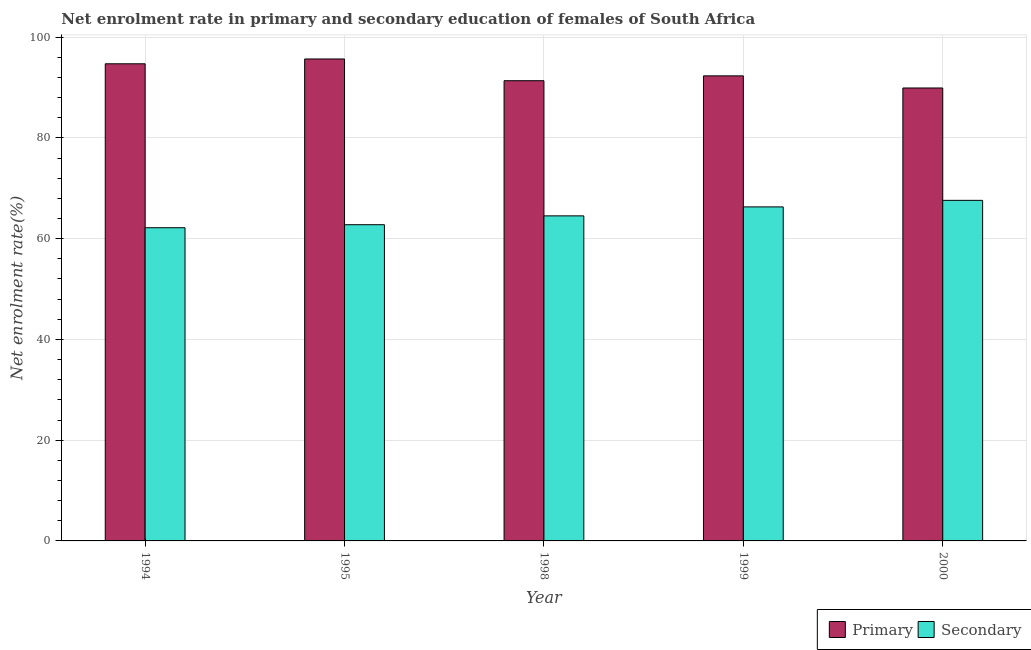How many different coloured bars are there?
Your answer should be very brief. 2. Are the number of bars per tick equal to the number of legend labels?
Your answer should be compact. Yes. How many bars are there on the 2nd tick from the left?
Offer a very short reply. 2. What is the label of the 5th group of bars from the left?
Your response must be concise. 2000. In how many cases, is the number of bars for a given year not equal to the number of legend labels?
Keep it short and to the point. 0. What is the enrollment rate in primary education in 1994?
Your answer should be very brief. 94.71. Across all years, what is the maximum enrollment rate in secondary education?
Your response must be concise. 67.6. Across all years, what is the minimum enrollment rate in secondary education?
Your answer should be compact. 62.17. In which year was the enrollment rate in primary education maximum?
Keep it short and to the point. 1995. What is the total enrollment rate in primary education in the graph?
Give a very brief answer. 463.95. What is the difference between the enrollment rate in primary education in 1995 and that in 1999?
Provide a short and direct response. 3.35. What is the difference between the enrollment rate in secondary education in 1994 and the enrollment rate in primary education in 1999?
Your answer should be compact. -4.14. What is the average enrollment rate in secondary education per year?
Provide a short and direct response. 64.67. In the year 1999, what is the difference between the enrollment rate in secondary education and enrollment rate in primary education?
Your response must be concise. 0. In how many years, is the enrollment rate in primary education greater than 80 %?
Offer a very short reply. 5. What is the ratio of the enrollment rate in primary education in 1994 to that in 1998?
Ensure brevity in your answer.  1.04. Is the enrollment rate in secondary education in 1994 less than that in 1998?
Ensure brevity in your answer.  Yes. Is the difference between the enrollment rate in secondary education in 1999 and 2000 greater than the difference between the enrollment rate in primary education in 1999 and 2000?
Offer a terse response. No. What is the difference between the highest and the second highest enrollment rate in primary education?
Your answer should be compact. 0.96. What is the difference between the highest and the lowest enrollment rate in primary education?
Make the answer very short. 5.76. In how many years, is the enrollment rate in primary education greater than the average enrollment rate in primary education taken over all years?
Provide a short and direct response. 2. What does the 2nd bar from the left in 1999 represents?
Provide a succinct answer. Secondary. What does the 2nd bar from the right in 1998 represents?
Your response must be concise. Primary. Are all the bars in the graph horizontal?
Offer a very short reply. No. How many years are there in the graph?
Provide a succinct answer. 5. What is the difference between two consecutive major ticks on the Y-axis?
Keep it short and to the point. 20. Are the values on the major ticks of Y-axis written in scientific E-notation?
Keep it short and to the point. No. Does the graph contain grids?
Offer a terse response. Yes. Where does the legend appear in the graph?
Offer a very short reply. Bottom right. How many legend labels are there?
Your answer should be compact. 2. What is the title of the graph?
Make the answer very short. Net enrolment rate in primary and secondary education of females of South Africa. What is the label or title of the X-axis?
Ensure brevity in your answer.  Year. What is the label or title of the Y-axis?
Your response must be concise. Net enrolment rate(%). What is the Net enrolment rate(%) of Primary in 1994?
Keep it short and to the point. 94.71. What is the Net enrolment rate(%) in Secondary in 1994?
Offer a very short reply. 62.17. What is the Net enrolment rate(%) of Primary in 1995?
Give a very brief answer. 95.67. What is the Net enrolment rate(%) in Secondary in 1995?
Your answer should be very brief. 62.77. What is the Net enrolment rate(%) in Primary in 1998?
Your answer should be very brief. 91.35. What is the Net enrolment rate(%) of Secondary in 1998?
Your answer should be compact. 64.52. What is the Net enrolment rate(%) of Primary in 1999?
Offer a very short reply. 92.31. What is the Net enrolment rate(%) in Secondary in 1999?
Provide a short and direct response. 66.3. What is the Net enrolment rate(%) of Primary in 2000?
Give a very brief answer. 89.91. What is the Net enrolment rate(%) in Secondary in 2000?
Your answer should be very brief. 67.6. Across all years, what is the maximum Net enrolment rate(%) in Primary?
Your response must be concise. 95.67. Across all years, what is the maximum Net enrolment rate(%) in Secondary?
Provide a succinct answer. 67.6. Across all years, what is the minimum Net enrolment rate(%) of Primary?
Offer a terse response. 89.91. Across all years, what is the minimum Net enrolment rate(%) of Secondary?
Make the answer very short. 62.17. What is the total Net enrolment rate(%) of Primary in the graph?
Offer a very short reply. 463.95. What is the total Net enrolment rate(%) of Secondary in the graph?
Keep it short and to the point. 323.37. What is the difference between the Net enrolment rate(%) of Primary in 1994 and that in 1995?
Give a very brief answer. -0.96. What is the difference between the Net enrolment rate(%) of Secondary in 1994 and that in 1995?
Offer a very short reply. -0.6. What is the difference between the Net enrolment rate(%) of Primary in 1994 and that in 1998?
Keep it short and to the point. 3.36. What is the difference between the Net enrolment rate(%) in Secondary in 1994 and that in 1998?
Offer a terse response. -2.36. What is the difference between the Net enrolment rate(%) of Primary in 1994 and that in 1999?
Keep it short and to the point. 2.4. What is the difference between the Net enrolment rate(%) in Secondary in 1994 and that in 1999?
Provide a succinct answer. -4.14. What is the difference between the Net enrolment rate(%) of Primary in 1994 and that in 2000?
Ensure brevity in your answer.  4.8. What is the difference between the Net enrolment rate(%) of Secondary in 1994 and that in 2000?
Make the answer very short. -5.44. What is the difference between the Net enrolment rate(%) in Primary in 1995 and that in 1998?
Give a very brief answer. 4.31. What is the difference between the Net enrolment rate(%) in Secondary in 1995 and that in 1998?
Provide a succinct answer. -1.76. What is the difference between the Net enrolment rate(%) in Primary in 1995 and that in 1999?
Your answer should be compact. 3.35. What is the difference between the Net enrolment rate(%) in Secondary in 1995 and that in 1999?
Give a very brief answer. -3.54. What is the difference between the Net enrolment rate(%) of Primary in 1995 and that in 2000?
Provide a short and direct response. 5.76. What is the difference between the Net enrolment rate(%) of Secondary in 1995 and that in 2000?
Offer a terse response. -4.84. What is the difference between the Net enrolment rate(%) in Primary in 1998 and that in 1999?
Keep it short and to the point. -0.96. What is the difference between the Net enrolment rate(%) of Secondary in 1998 and that in 1999?
Make the answer very short. -1.78. What is the difference between the Net enrolment rate(%) of Primary in 1998 and that in 2000?
Provide a short and direct response. 1.45. What is the difference between the Net enrolment rate(%) in Secondary in 1998 and that in 2000?
Your response must be concise. -3.08. What is the difference between the Net enrolment rate(%) of Primary in 1999 and that in 2000?
Give a very brief answer. 2.41. What is the difference between the Net enrolment rate(%) of Secondary in 1999 and that in 2000?
Give a very brief answer. -1.3. What is the difference between the Net enrolment rate(%) of Primary in 1994 and the Net enrolment rate(%) of Secondary in 1995?
Keep it short and to the point. 31.94. What is the difference between the Net enrolment rate(%) of Primary in 1994 and the Net enrolment rate(%) of Secondary in 1998?
Offer a terse response. 30.19. What is the difference between the Net enrolment rate(%) of Primary in 1994 and the Net enrolment rate(%) of Secondary in 1999?
Provide a succinct answer. 28.41. What is the difference between the Net enrolment rate(%) in Primary in 1994 and the Net enrolment rate(%) in Secondary in 2000?
Provide a short and direct response. 27.11. What is the difference between the Net enrolment rate(%) in Primary in 1995 and the Net enrolment rate(%) in Secondary in 1998?
Provide a short and direct response. 31.14. What is the difference between the Net enrolment rate(%) of Primary in 1995 and the Net enrolment rate(%) of Secondary in 1999?
Your response must be concise. 29.36. What is the difference between the Net enrolment rate(%) of Primary in 1995 and the Net enrolment rate(%) of Secondary in 2000?
Provide a succinct answer. 28.06. What is the difference between the Net enrolment rate(%) in Primary in 1998 and the Net enrolment rate(%) in Secondary in 1999?
Provide a succinct answer. 25.05. What is the difference between the Net enrolment rate(%) of Primary in 1998 and the Net enrolment rate(%) of Secondary in 2000?
Keep it short and to the point. 23.75. What is the difference between the Net enrolment rate(%) in Primary in 1999 and the Net enrolment rate(%) in Secondary in 2000?
Your response must be concise. 24.71. What is the average Net enrolment rate(%) of Primary per year?
Offer a very short reply. 92.79. What is the average Net enrolment rate(%) in Secondary per year?
Offer a very short reply. 64.67. In the year 1994, what is the difference between the Net enrolment rate(%) in Primary and Net enrolment rate(%) in Secondary?
Your response must be concise. 32.54. In the year 1995, what is the difference between the Net enrolment rate(%) in Primary and Net enrolment rate(%) in Secondary?
Provide a succinct answer. 32.9. In the year 1998, what is the difference between the Net enrolment rate(%) in Primary and Net enrolment rate(%) in Secondary?
Make the answer very short. 26.83. In the year 1999, what is the difference between the Net enrolment rate(%) of Primary and Net enrolment rate(%) of Secondary?
Your response must be concise. 26.01. In the year 2000, what is the difference between the Net enrolment rate(%) in Primary and Net enrolment rate(%) in Secondary?
Provide a succinct answer. 22.3. What is the ratio of the Net enrolment rate(%) in Primary in 1994 to that in 1995?
Offer a very short reply. 0.99. What is the ratio of the Net enrolment rate(%) in Secondary in 1994 to that in 1995?
Provide a short and direct response. 0.99. What is the ratio of the Net enrolment rate(%) in Primary in 1994 to that in 1998?
Give a very brief answer. 1.04. What is the ratio of the Net enrolment rate(%) of Secondary in 1994 to that in 1998?
Ensure brevity in your answer.  0.96. What is the ratio of the Net enrolment rate(%) of Secondary in 1994 to that in 1999?
Your response must be concise. 0.94. What is the ratio of the Net enrolment rate(%) of Primary in 1994 to that in 2000?
Offer a terse response. 1.05. What is the ratio of the Net enrolment rate(%) in Secondary in 1994 to that in 2000?
Provide a short and direct response. 0.92. What is the ratio of the Net enrolment rate(%) in Primary in 1995 to that in 1998?
Your response must be concise. 1.05. What is the ratio of the Net enrolment rate(%) in Secondary in 1995 to that in 1998?
Make the answer very short. 0.97. What is the ratio of the Net enrolment rate(%) in Primary in 1995 to that in 1999?
Make the answer very short. 1.04. What is the ratio of the Net enrolment rate(%) of Secondary in 1995 to that in 1999?
Provide a short and direct response. 0.95. What is the ratio of the Net enrolment rate(%) in Primary in 1995 to that in 2000?
Give a very brief answer. 1.06. What is the ratio of the Net enrolment rate(%) in Secondary in 1995 to that in 2000?
Provide a succinct answer. 0.93. What is the ratio of the Net enrolment rate(%) of Primary in 1998 to that in 1999?
Provide a succinct answer. 0.99. What is the ratio of the Net enrolment rate(%) of Secondary in 1998 to that in 1999?
Keep it short and to the point. 0.97. What is the ratio of the Net enrolment rate(%) of Primary in 1998 to that in 2000?
Ensure brevity in your answer.  1.02. What is the ratio of the Net enrolment rate(%) of Secondary in 1998 to that in 2000?
Provide a succinct answer. 0.95. What is the ratio of the Net enrolment rate(%) of Primary in 1999 to that in 2000?
Give a very brief answer. 1.03. What is the ratio of the Net enrolment rate(%) in Secondary in 1999 to that in 2000?
Provide a short and direct response. 0.98. What is the difference between the highest and the second highest Net enrolment rate(%) in Primary?
Give a very brief answer. 0.96. What is the difference between the highest and the second highest Net enrolment rate(%) of Secondary?
Your answer should be very brief. 1.3. What is the difference between the highest and the lowest Net enrolment rate(%) in Primary?
Give a very brief answer. 5.76. What is the difference between the highest and the lowest Net enrolment rate(%) in Secondary?
Make the answer very short. 5.44. 